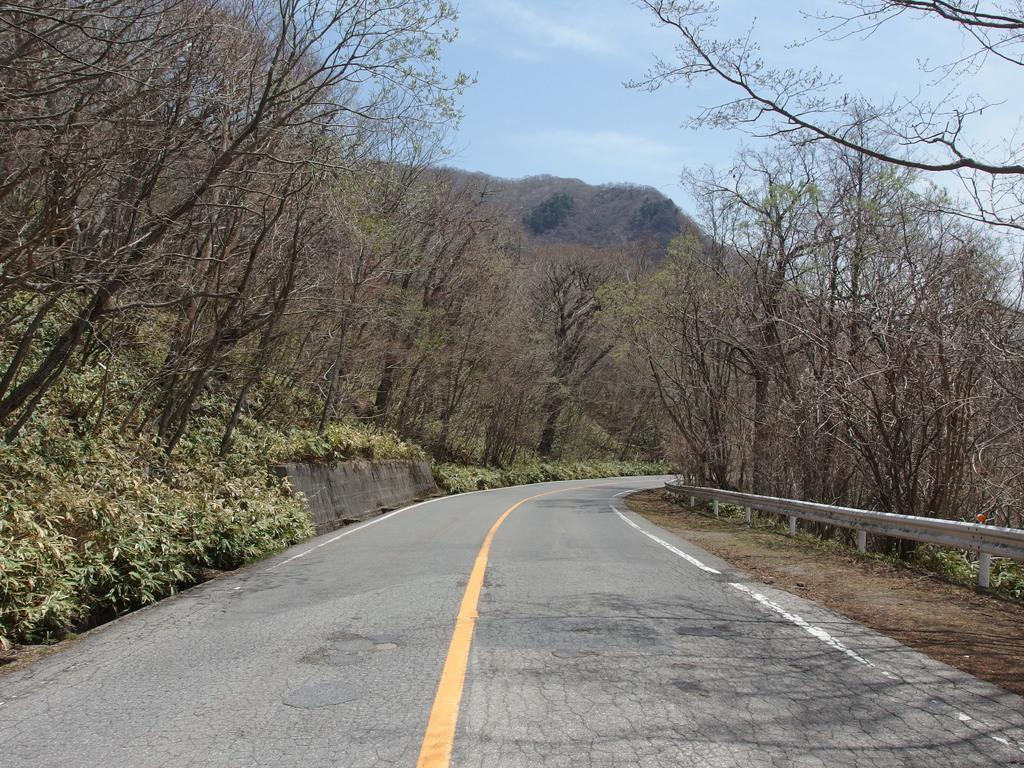What is the main feature in the center of the image? There is a road in the center of the image. What can be seen on the left side of the image? There is a fence on the left side of the image. What type of vegetation is present on the left side of the road? There are trees on the left side of the road. What type of vegetation is present on the right side of the road? There are trees on the right side of the road. Can you see a hook hanging from the trees on the right side of the road? There is no hook visible in the image; only trees are present on the right side of the road. 